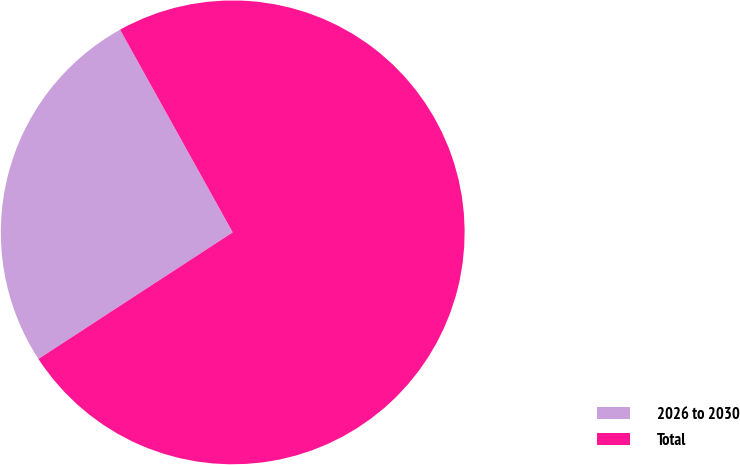Convert chart. <chart><loc_0><loc_0><loc_500><loc_500><pie_chart><fcel>2026 to 2030<fcel>Total<nl><fcel>26.12%<fcel>73.88%<nl></chart> 